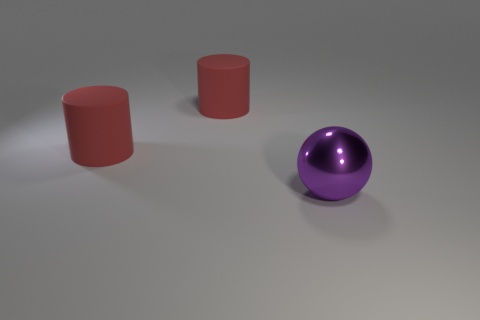Add 1 red metal things. How many objects exist? 4 Subtract 1 spheres. How many spheres are left? 0 Subtract all cylinders. How many objects are left? 1 Add 2 large purple metallic spheres. How many large purple metallic spheres are left? 3 Add 2 large purple spheres. How many large purple spheres exist? 3 Subtract 0 gray cylinders. How many objects are left? 3 Subtract all brown cylinders. Subtract all gray blocks. How many cylinders are left? 2 Subtract all small gray cubes. Subtract all large cylinders. How many objects are left? 1 